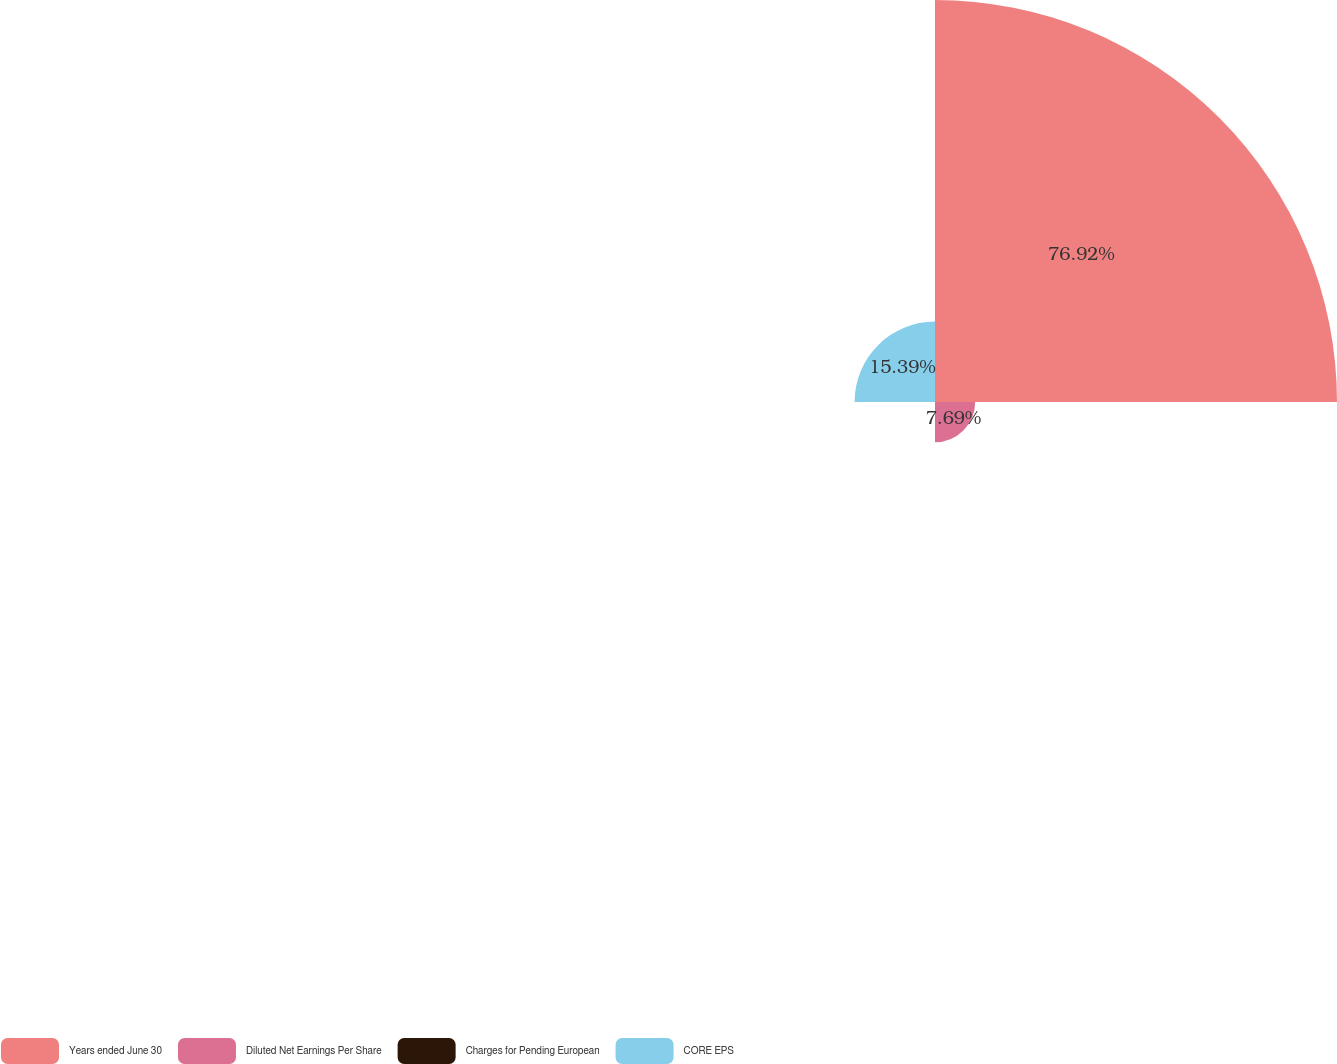Convert chart. <chart><loc_0><loc_0><loc_500><loc_500><pie_chart><fcel>Years ended June 30<fcel>Diluted Net Earnings Per Share<fcel>Charges for Pending European<fcel>CORE EPS<nl><fcel>76.92%<fcel>7.69%<fcel>0.0%<fcel>15.39%<nl></chart> 